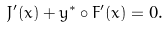Convert formula to latex. <formula><loc_0><loc_0><loc_500><loc_500>J ^ { \prime } ( \bar { x } ) + y ^ { * } \circ F ^ { \prime } ( \bar { x } ) = 0 .</formula> 